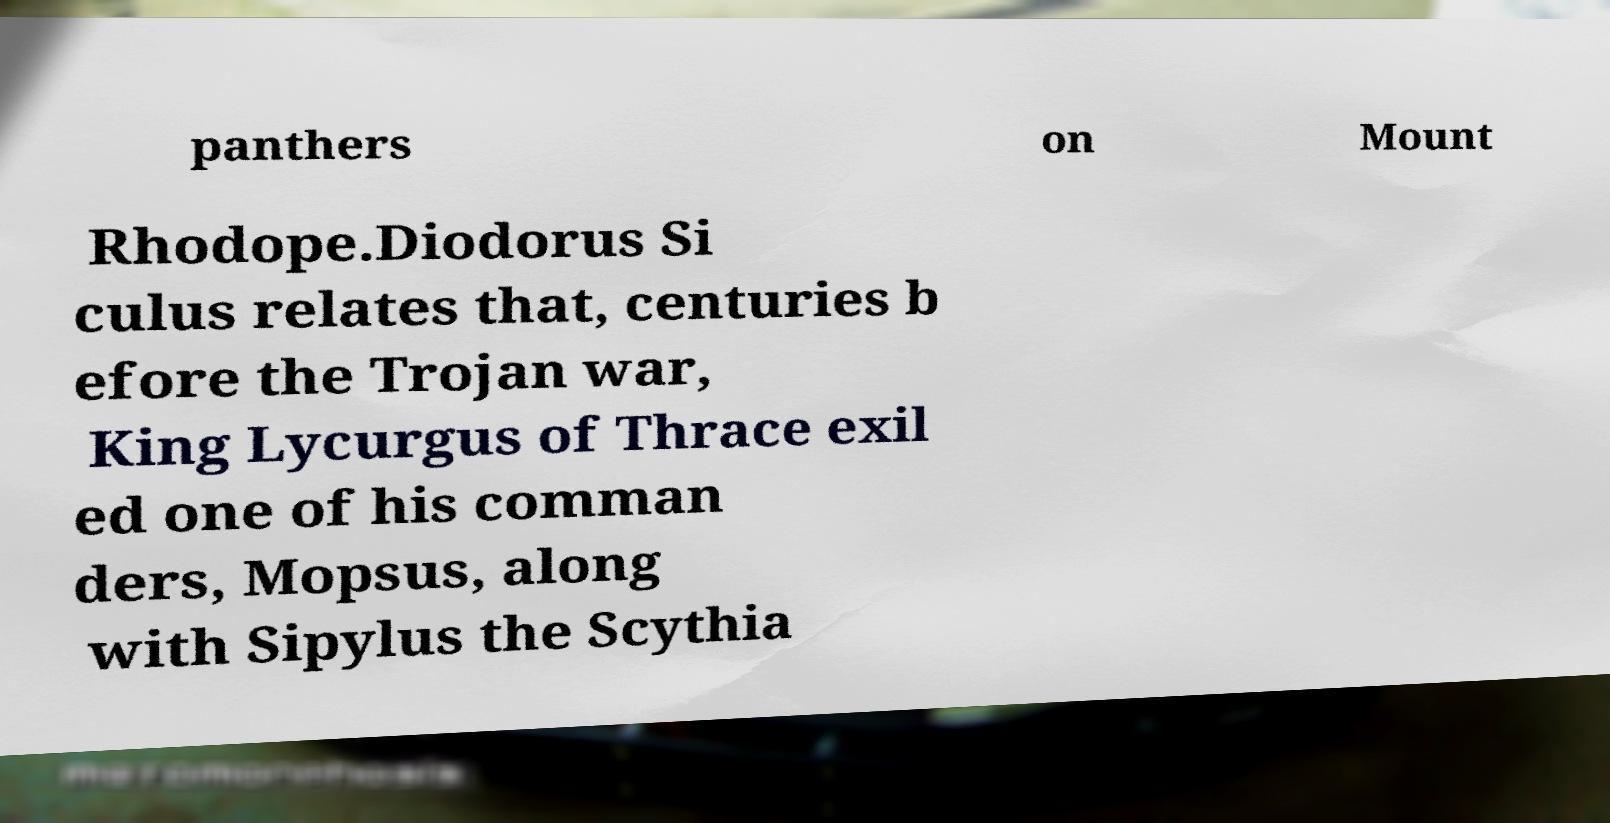Could you extract and type out the text from this image? panthers on Mount Rhodope.Diodorus Si culus relates that, centuries b efore the Trojan war, King Lycurgus of Thrace exil ed one of his comman ders, Mopsus, along with Sipylus the Scythia 